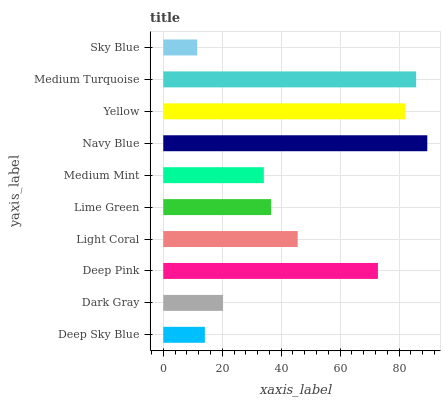Is Sky Blue the minimum?
Answer yes or no. Yes. Is Navy Blue the maximum?
Answer yes or no. Yes. Is Dark Gray the minimum?
Answer yes or no. No. Is Dark Gray the maximum?
Answer yes or no. No. Is Dark Gray greater than Deep Sky Blue?
Answer yes or no. Yes. Is Deep Sky Blue less than Dark Gray?
Answer yes or no. Yes. Is Deep Sky Blue greater than Dark Gray?
Answer yes or no. No. Is Dark Gray less than Deep Sky Blue?
Answer yes or no. No. Is Light Coral the high median?
Answer yes or no. Yes. Is Lime Green the low median?
Answer yes or no. Yes. Is Sky Blue the high median?
Answer yes or no. No. Is Sky Blue the low median?
Answer yes or no. No. 